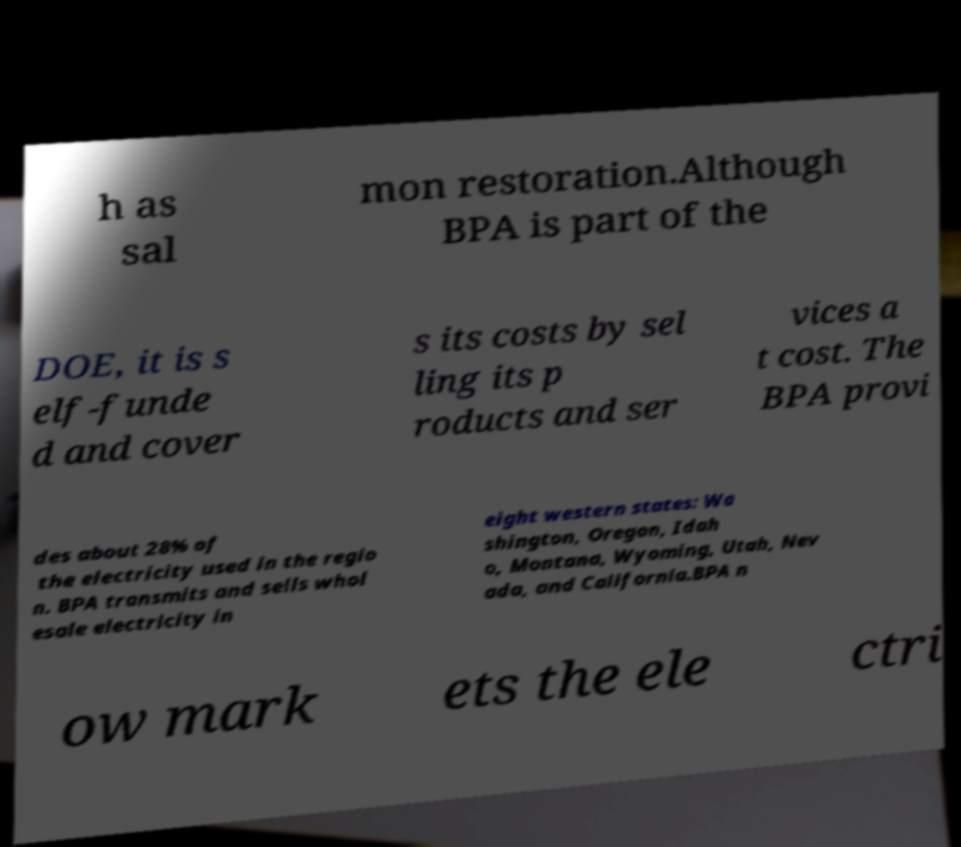Can you read and provide the text displayed in the image?This photo seems to have some interesting text. Can you extract and type it out for me? h as sal mon restoration.Although BPA is part of the DOE, it is s elf-funde d and cover s its costs by sel ling its p roducts and ser vices a t cost. The BPA provi des about 28% of the electricity used in the regio n. BPA transmits and sells whol esale electricity in eight western states: Wa shington, Oregon, Idah o, Montana, Wyoming, Utah, Nev ada, and California.BPA n ow mark ets the ele ctri 